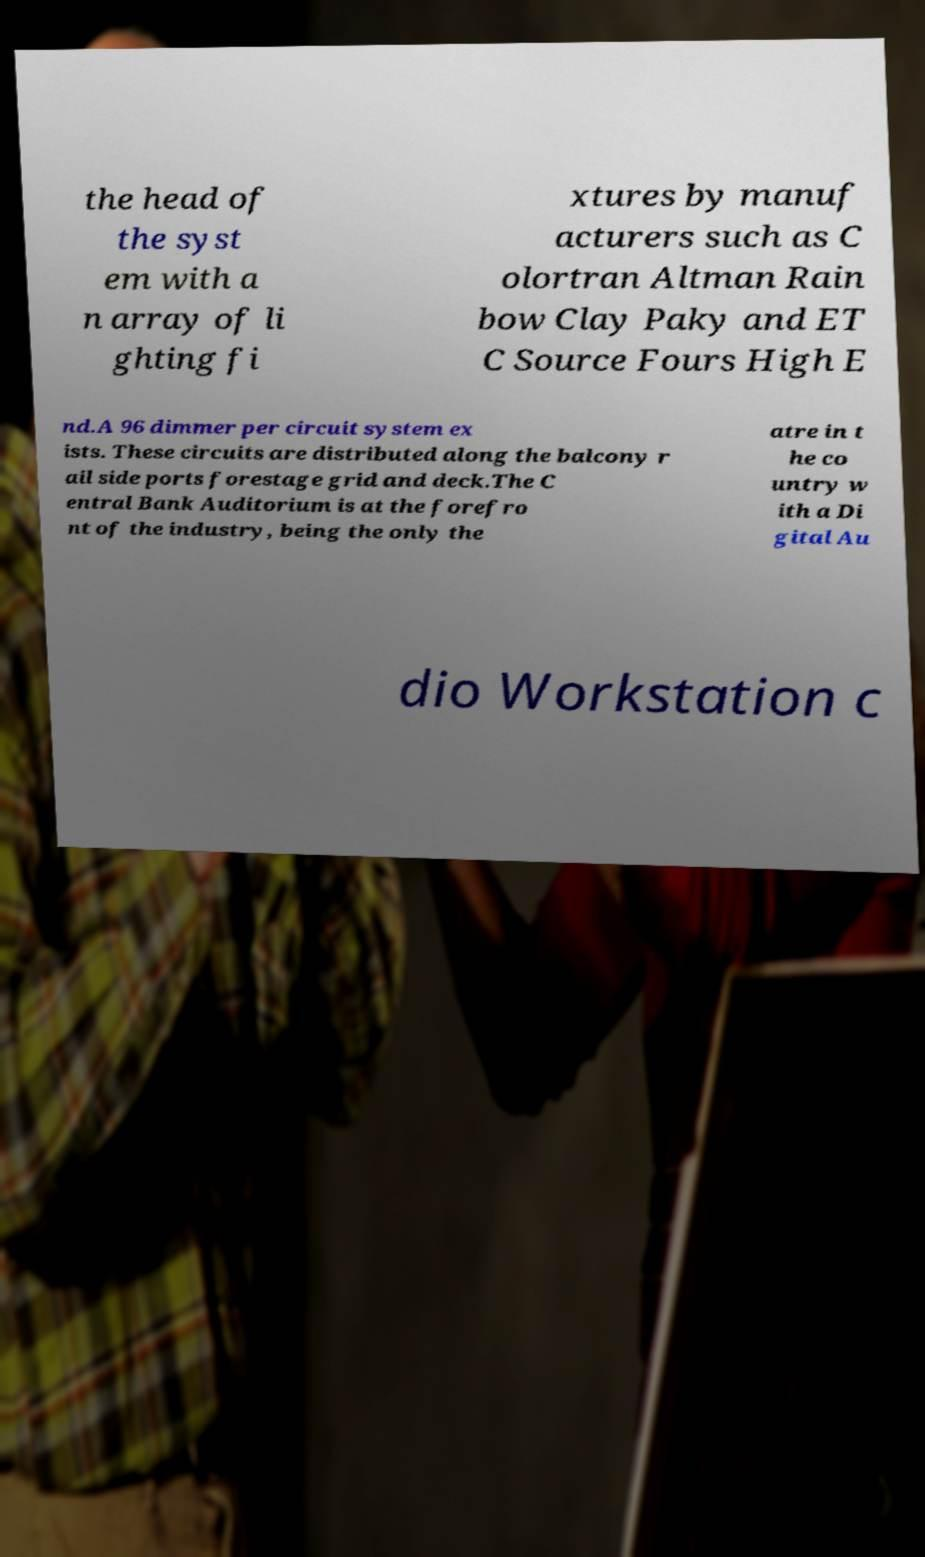Could you assist in decoding the text presented in this image and type it out clearly? the head of the syst em with a n array of li ghting fi xtures by manuf acturers such as C olortran Altman Rain bow Clay Paky and ET C Source Fours High E nd.A 96 dimmer per circuit system ex ists. These circuits are distributed along the balcony r ail side ports forestage grid and deck.The C entral Bank Auditorium is at the forefro nt of the industry, being the only the atre in t he co untry w ith a Di gital Au dio Workstation c 